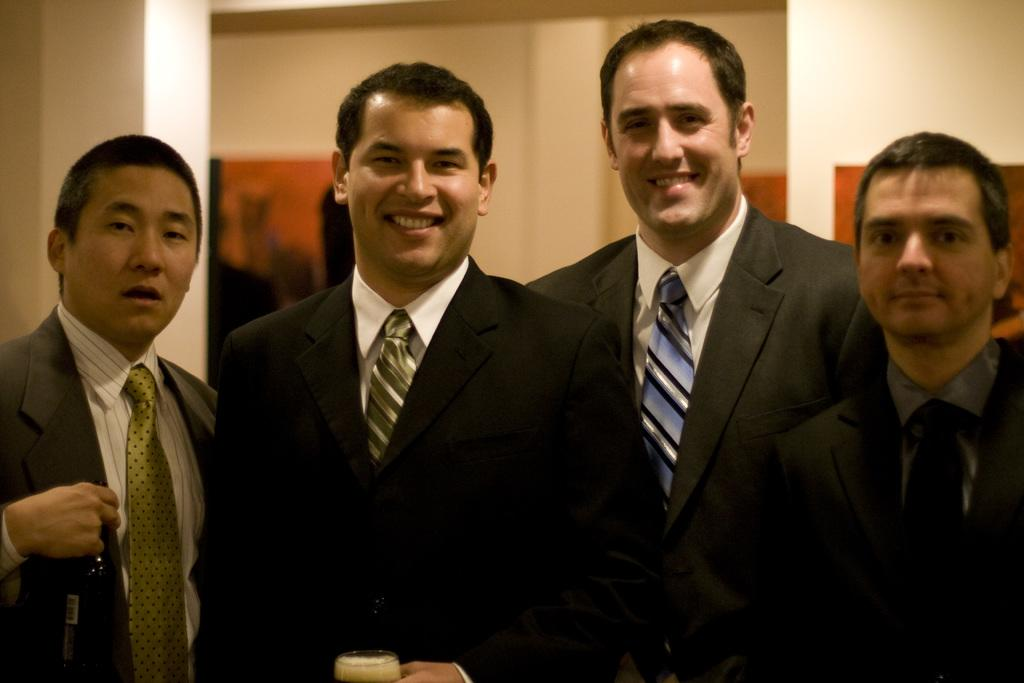How many people are in the image? There are four men in the image. What are the men wearing? The men are wearing suits and ties. Can you describe the facial expressions of the men? Two of the men are smiling. What is one of the men holding? One man is holding a cup. What type of curve can be seen in the image? There is no curve present in the image. What act are the men performing in the image? The image does not depict any specific act or performance. 